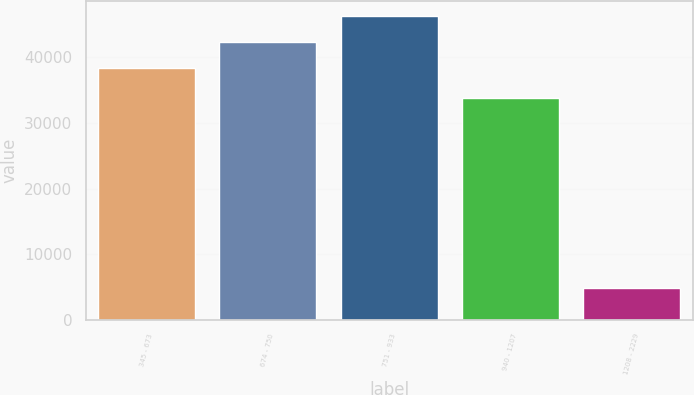<chart> <loc_0><loc_0><loc_500><loc_500><bar_chart><fcel>345 - 673<fcel>674 - 750<fcel>751 - 933<fcel>940 - 1207<fcel>1208 - 2229<nl><fcel>38373<fcel>42327.7<fcel>46282.4<fcel>33787<fcel>4792<nl></chart> 